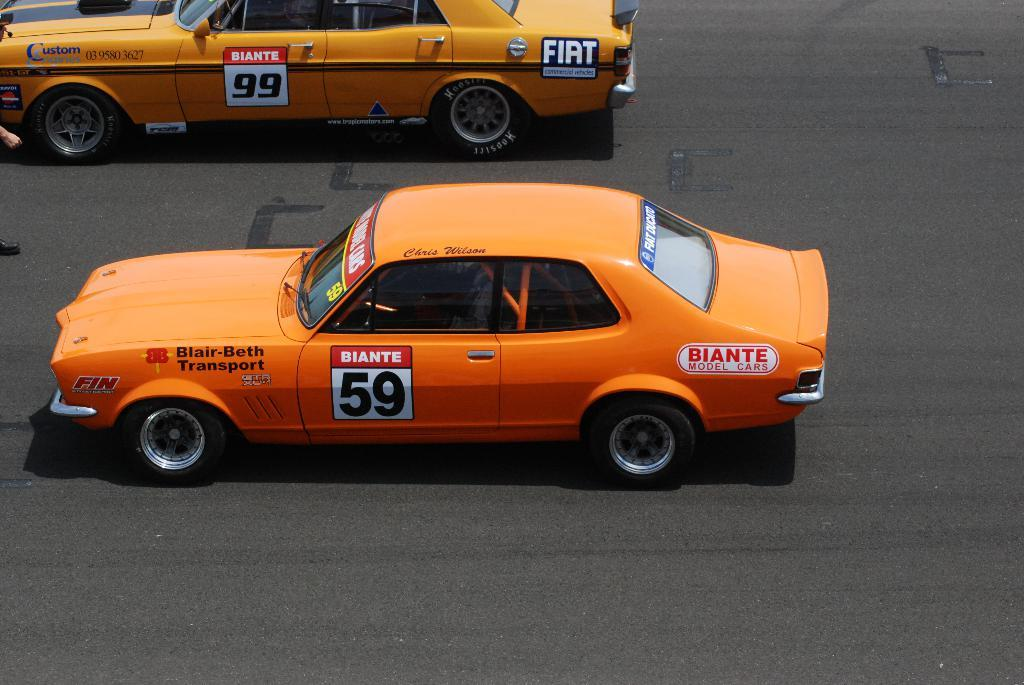How many cars are visible on the road in the image? There are two cars on the road in the image. Can you describe the position of the person in the image? A person is standing on the left side of the road in the image. What page is the person reading from while standing on the left side of the road? There is no indication in the image that the person is reading from a page, as they are simply standing on the left side of the road. Is the person's toe visible in the image? The image does not provide enough detail to determine if the person's toe is visible or not. 